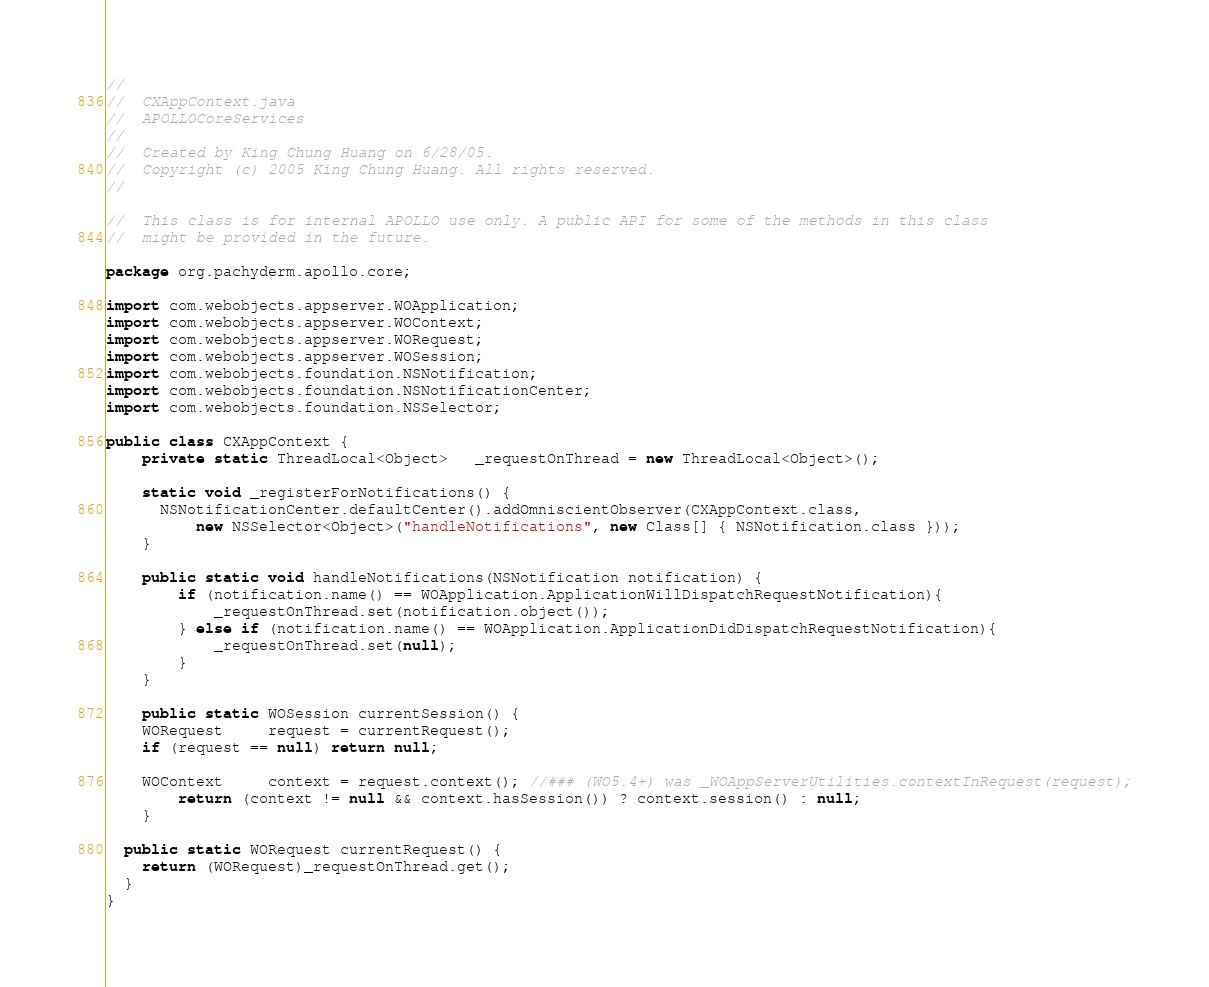<code> <loc_0><loc_0><loc_500><loc_500><_Java_>//
//  CXAppContext.java
//  APOLLOCoreServices
//
//  Created by King Chung Huang on 6/28/05.
//  Copyright (c) 2005 King Chung Huang. All rights reserved.
//

//	This class is for internal APOLLO use only. A public API for some of the methods in this class 
//  might be provided in the future.

package org.pachyderm.apollo.core;

import com.webobjects.appserver.WOApplication;
import com.webobjects.appserver.WOContext;
import com.webobjects.appserver.WORequest;
import com.webobjects.appserver.WOSession;
import com.webobjects.foundation.NSNotification;
import com.webobjects.foundation.NSNotificationCenter;
import com.webobjects.foundation.NSSelector;

public class CXAppContext {
	private static ThreadLocal<Object>   _requestOnThread = new ThreadLocal<Object>();
	
	static void _registerForNotifications() {
	  NSNotificationCenter.defaultCenter().addOmniscientObserver(CXAppContext.class,
	      new NSSelector<Object>("handleNotifications", new Class[] { NSNotification.class }));
	}
	
	public static void handleNotifications(NSNotification notification) {
		if (notification.name() == WOApplication.ApplicationWillDispatchRequestNotification){
			_requestOnThread.set(notification.object());
		} else if (notification.name() == WOApplication.ApplicationDidDispatchRequestNotification){
			_requestOnThread.set(null);
		}
	}
	
	public static WOSession currentSession() {
    WORequest     request = currentRequest();
    if (request == null) return null;
    
    WOContext     context = request.context(); //### (WO5.4+) was _WOAppServerUtilities.contextInRequest(request);
		return (context != null && context.hasSession()) ? context.session() : null;
	}
	
  public static WORequest currentRequest() {
    return (WORequest)_requestOnThread.get();
  }
}</code> 